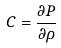Convert formula to latex. <formula><loc_0><loc_0><loc_500><loc_500>C = \frac { \partial P } { \partial \rho }</formula> 